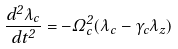<formula> <loc_0><loc_0><loc_500><loc_500>\frac { d ^ { 2 } \lambda _ { c } } { d t ^ { 2 } } = - \Omega _ { c } ^ { 2 } ( \lambda _ { c } - \gamma _ { c } \lambda _ { z } )</formula> 